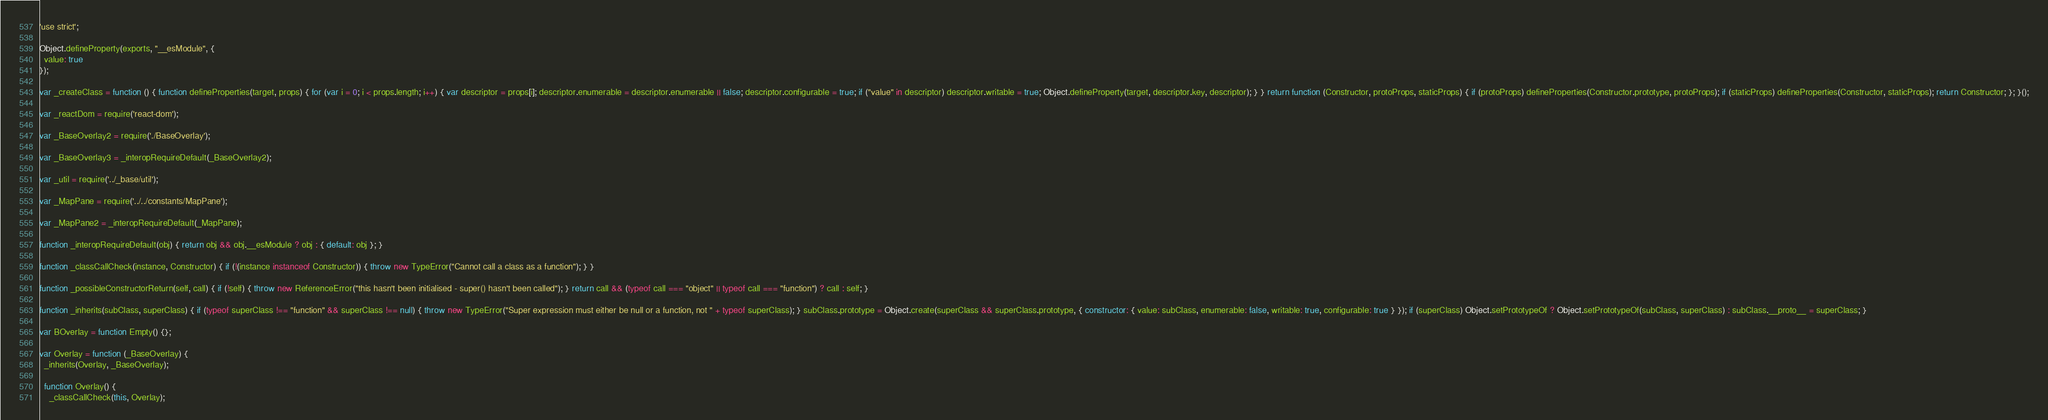Convert code to text. <code><loc_0><loc_0><loc_500><loc_500><_JavaScript_>'use strict';

Object.defineProperty(exports, "__esModule", {
  value: true
});

var _createClass = function () { function defineProperties(target, props) { for (var i = 0; i < props.length; i++) { var descriptor = props[i]; descriptor.enumerable = descriptor.enumerable || false; descriptor.configurable = true; if ("value" in descriptor) descriptor.writable = true; Object.defineProperty(target, descriptor.key, descriptor); } } return function (Constructor, protoProps, staticProps) { if (protoProps) defineProperties(Constructor.prototype, protoProps); if (staticProps) defineProperties(Constructor, staticProps); return Constructor; }; }();

var _reactDom = require('react-dom');

var _BaseOverlay2 = require('./BaseOverlay');

var _BaseOverlay3 = _interopRequireDefault(_BaseOverlay2);

var _util = require('../_base/util');

var _MapPane = require('../../constants/MapPane');

var _MapPane2 = _interopRequireDefault(_MapPane);

function _interopRequireDefault(obj) { return obj && obj.__esModule ? obj : { default: obj }; }

function _classCallCheck(instance, Constructor) { if (!(instance instanceof Constructor)) { throw new TypeError("Cannot call a class as a function"); } }

function _possibleConstructorReturn(self, call) { if (!self) { throw new ReferenceError("this hasn't been initialised - super() hasn't been called"); } return call && (typeof call === "object" || typeof call === "function") ? call : self; }

function _inherits(subClass, superClass) { if (typeof superClass !== "function" && superClass !== null) { throw new TypeError("Super expression must either be null or a function, not " + typeof superClass); } subClass.prototype = Object.create(superClass && superClass.prototype, { constructor: { value: subClass, enumerable: false, writable: true, configurable: true } }); if (superClass) Object.setPrototypeOf ? Object.setPrototypeOf(subClass, superClass) : subClass.__proto__ = superClass; }

var BOverlay = function Empty() {};

var Overlay = function (_BaseOverlay) {
  _inherits(Overlay, _BaseOverlay);

  function Overlay() {
    _classCallCheck(this, Overlay);
</code> 